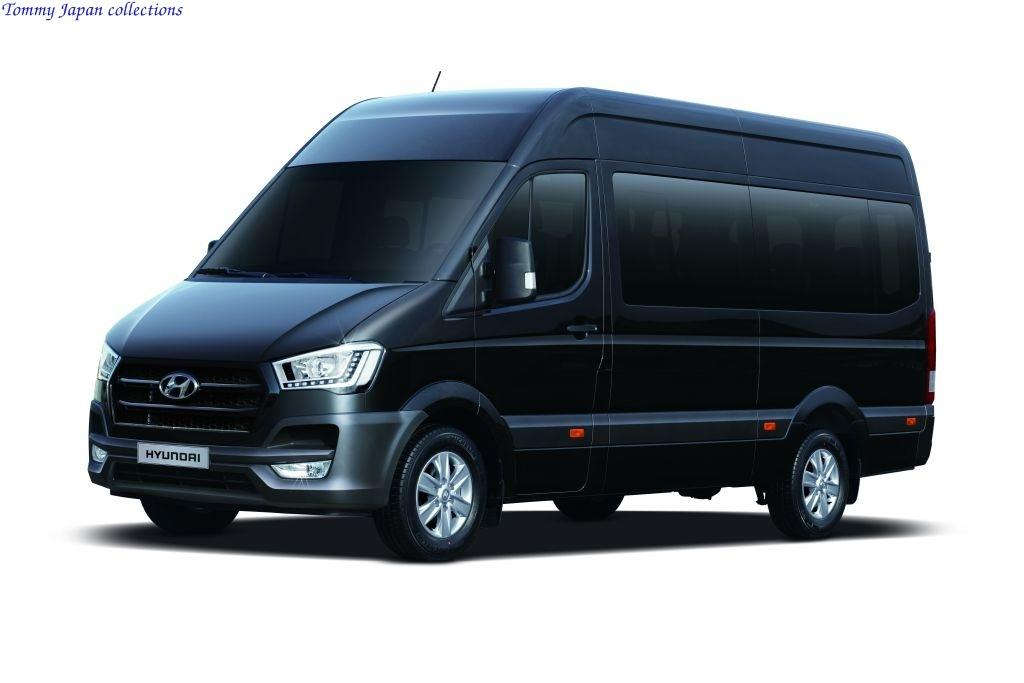Provide a one-sentence caption for the provided image. A large black Hyundai work van by Tommy Japan collections. 